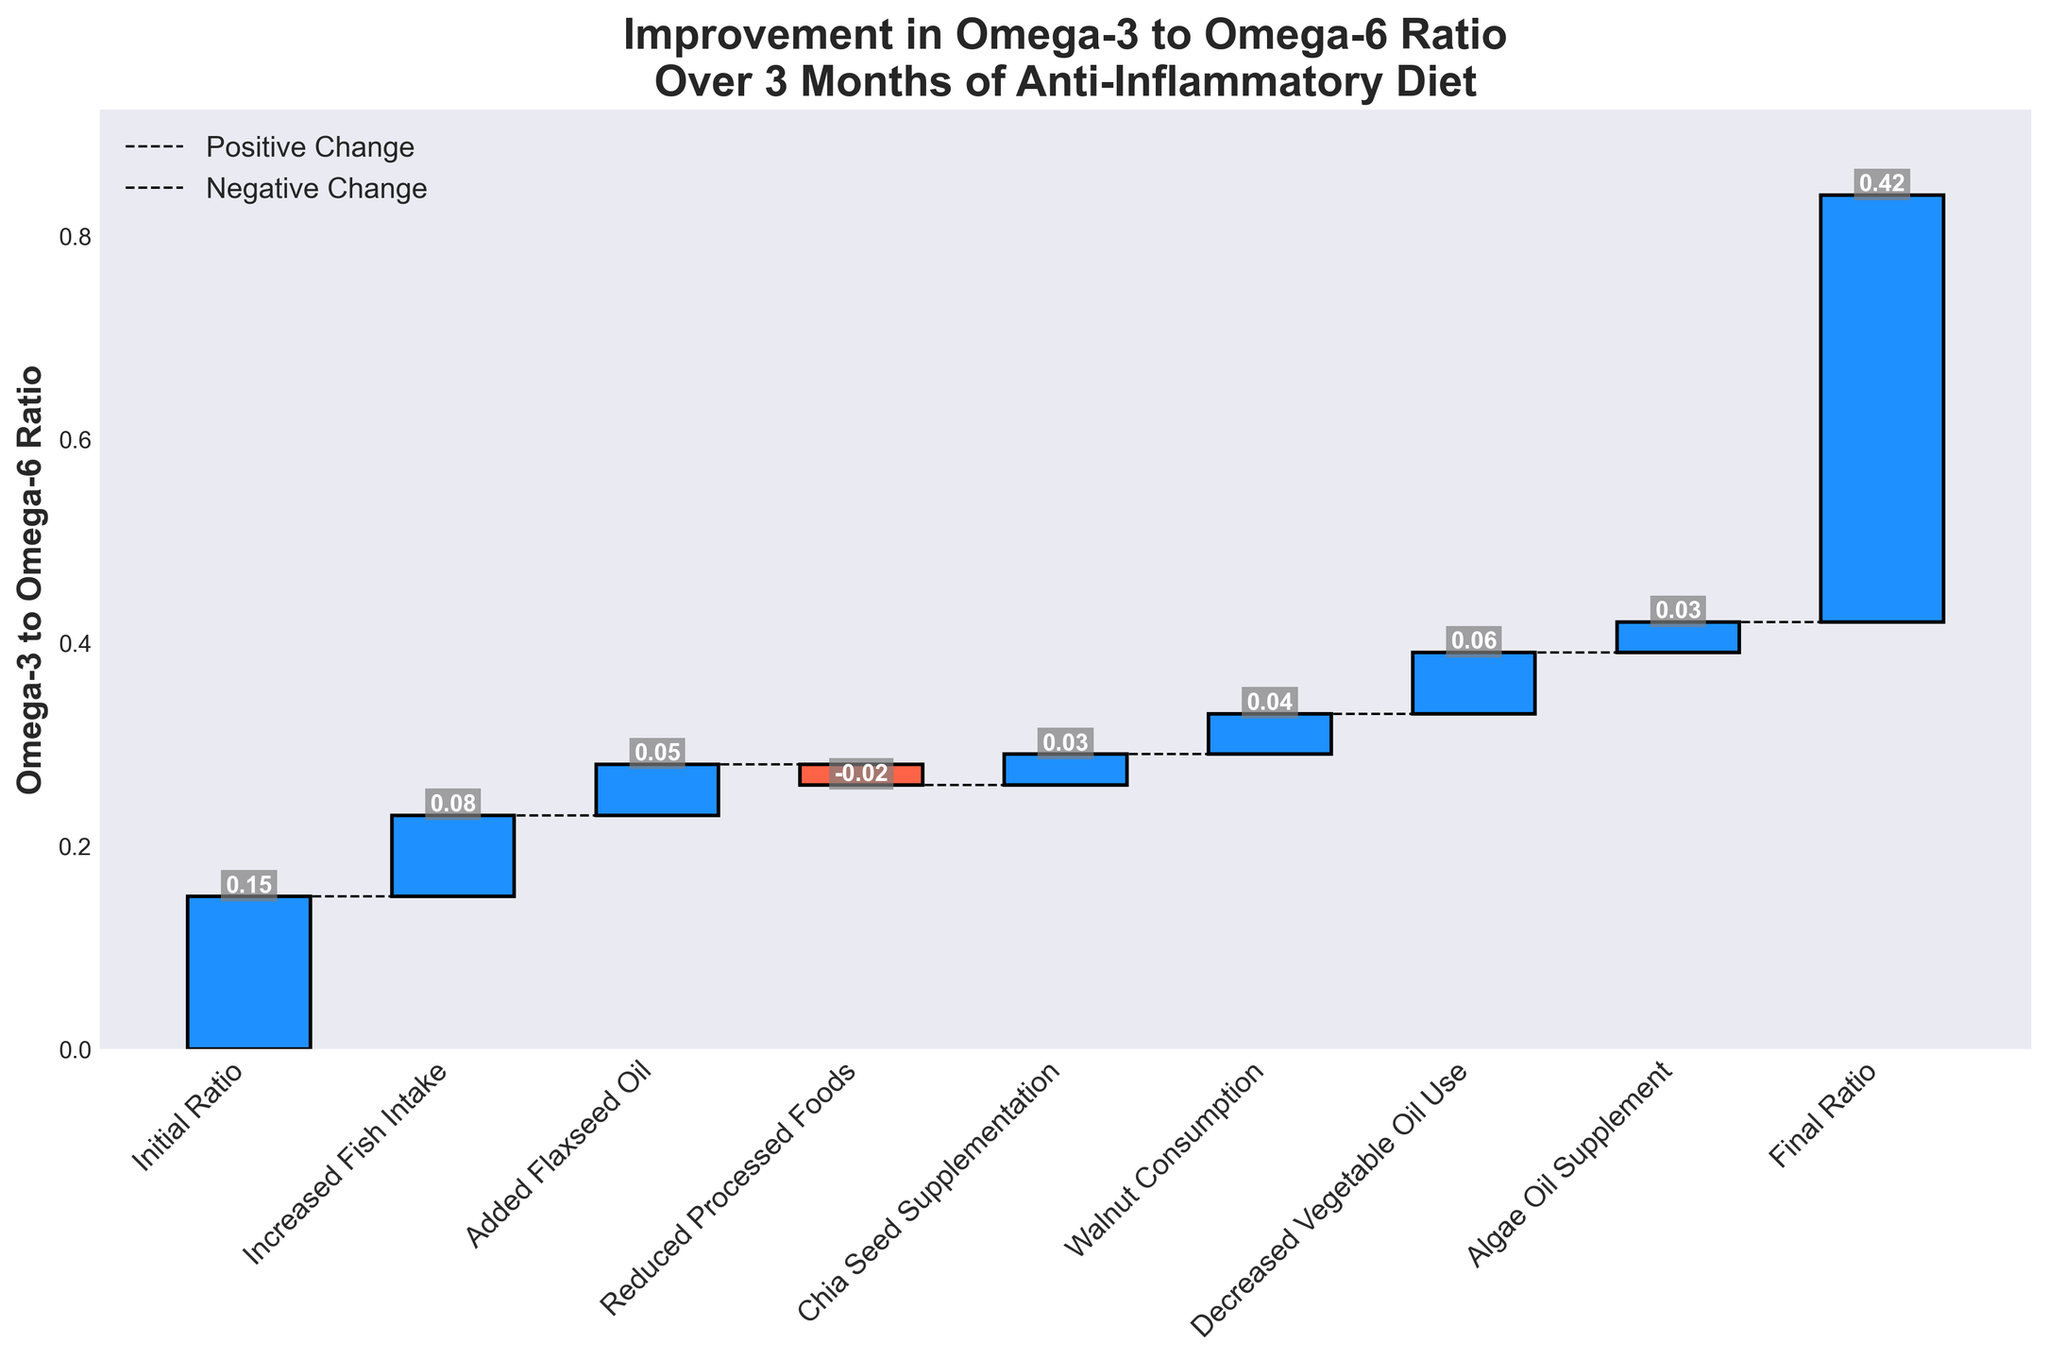What is the title of the figure? The title is usually at the top of the figure. It describes what the figure is about.
Answer: "Improvement in Omega-3 to Omega-6 Ratio\nOver 3 Months of Anti-Inflammatory Diet" How many different categories are displayed in the figure? By counting the number of x-axis labels or bars, we can determine the number of different categories.
Answer: 8 Which category contributed the most positive change in the omega-3 to omega-6 ratio? By comparing the heights of the bars that represent positive changes, we can identify which one is the tallest.
Answer: Decreased Vegetable Oil Use Which category contributed a negative change in the omega-3 to omega-6 ratio? By looking for the bar(s) that are colored differently, indicating negative values, we can find the category that contributed a negative change.
Answer: Reduced Processed Foods What is the final omega-3 to omega-6 ratio after the 3 months? The final value is usually indicated at the end of the cumulative sum. By looking at the text label at the top of the last bar, we can find it.
Answer: 0.42 What is the cumulative improvement in ratio by Increased Fish Intake and Added Flaxseed Oil? Sum the values of both categories' contributions to find the cumulative improvement. Increased Fish Intake = 0.08, Added Flaxseed Oil = 0.05, so 0.08 + 0.05 = 0.13
Answer: 0.13 What is the difference in contribution between Walnut Consumption and Reduced Processed Foods? Find the values for both categories and subtract the smaller value from the larger one. Walnut Consumption = 0.04, Reduced Processed Foods = -0.02, so 0.04 - (-0.02) = 0.06
Answer: 0.06 If you were to add the contributions of Chia Seed Supplementation and Algae Oil Supplement, how does that total compare to the contribution of Decreased Vegetable Oil Use? Sum the contributions of Chia Seed Supplementation and Algae Oil Supplement and compare it to Decreased Vegetable Oil Use. Chia Seed Supplementation = 0.03, Algae Oil Supplement = 0.03, total = 0.03 + 0.03 = 0.06. Decreased Vegetable Oil Use = 0.06, so they are equal.
Answer: Equal What are the colors used to show positive and negative changes in the omega-3 to omega-6 ratio? By looking at the figure, we can identify the colors used for positive and negative changes.
Answer: Positive changes are blue, negative changes are red What is the overall improvement in the omega-3 to omega-6 ratio over the three months? Subtract the initial ratio from the final ratio to find the overall improvement. Final Ratio = 0.42, Initial Ratio = 0.15, so 0.42 - 0.15 = 0.27
Answer: 0.27 